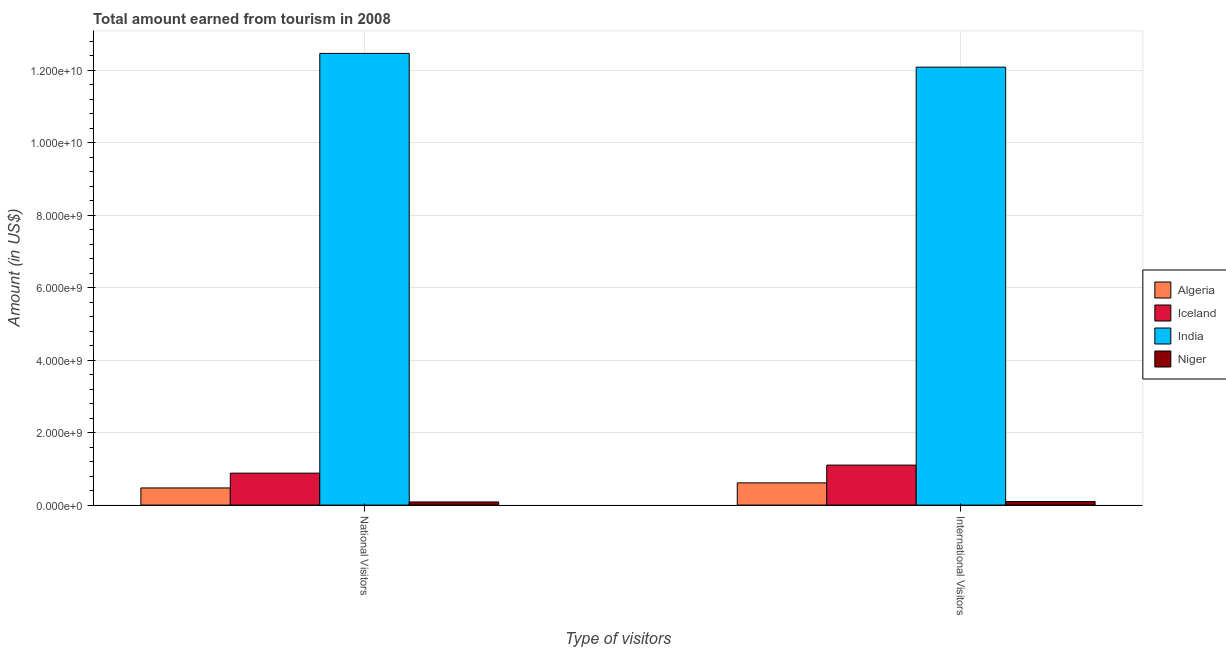How many different coloured bars are there?
Offer a terse response. 4. Are the number of bars per tick equal to the number of legend labels?
Keep it short and to the point. Yes. Are the number of bars on each tick of the X-axis equal?
Offer a very short reply. Yes. How many bars are there on the 1st tick from the left?
Your answer should be compact. 4. What is the label of the 1st group of bars from the left?
Provide a succinct answer. National Visitors. What is the amount earned from international visitors in Niger?
Your answer should be compact. 9.80e+07. Across all countries, what is the maximum amount earned from international visitors?
Your response must be concise. 1.21e+1. Across all countries, what is the minimum amount earned from international visitors?
Offer a terse response. 9.80e+07. In which country was the amount earned from international visitors minimum?
Offer a very short reply. Niger. What is the total amount earned from national visitors in the graph?
Make the answer very short. 1.39e+1. What is the difference between the amount earned from national visitors in Niger and that in Iceland?
Offer a very short reply. -7.95e+08. What is the difference between the amount earned from international visitors in Niger and the amount earned from national visitors in Iceland?
Your answer should be very brief. -7.83e+08. What is the average amount earned from international visitors per country?
Your response must be concise. 3.47e+09. What is the difference between the amount earned from international visitors and amount earned from national visitors in Iceland?
Offer a very short reply. 2.22e+08. In how many countries, is the amount earned from international visitors greater than 5600000000 US$?
Your answer should be very brief. 1. What is the ratio of the amount earned from national visitors in Niger to that in Iceland?
Offer a very short reply. 0.1. What does the 1st bar from the left in International Visitors represents?
Give a very brief answer. Algeria. What does the 1st bar from the right in National Visitors represents?
Provide a short and direct response. Niger. Are all the bars in the graph horizontal?
Offer a very short reply. No. How many countries are there in the graph?
Ensure brevity in your answer.  4. Does the graph contain any zero values?
Offer a terse response. No. Where does the legend appear in the graph?
Give a very brief answer. Center right. What is the title of the graph?
Provide a succinct answer. Total amount earned from tourism in 2008. Does "Andorra" appear as one of the legend labels in the graph?
Keep it short and to the point. No. What is the label or title of the X-axis?
Your response must be concise. Type of visitors. What is the label or title of the Y-axis?
Make the answer very short. Amount (in US$). What is the Amount (in US$) of Algeria in National Visitors?
Give a very brief answer. 4.73e+08. What is the Amount (in US$) of Iceland in National Visitors?
Your response must be concise. 8.81e+08. What is the Amount (in US$) in India in National Visitors?
Give a very brief answer. 1.25e+1. What is the Amount (in US$) in Niger in National Visitors?
Make the answer very short. 8.60e+07. What is the Amount (in US$) in Algeria in International Visitors?
Your response must be concise. 6.13e+08. What is the Amount (in US$) in Iceland in International Visitors?
Keep it short and to the point. 1.10e+09. What is the Amount (in US$) in India in International Visitors?
Offer a terse response. 1.21e+1. What is the Amount (in US$) in Niger in International Visitors?
Your answer should be compact. 9.80e+07. Across all Type of visitors, what is the maximum Amount (in US$) in Algeria?
Keep it short and to the point. 6.13e+08. Across all Type of visitors, what is the maximum Amount (in US$) in Iceland?
Ensure brevity in your answer.  1.10e+09. Across all Type of visitors, what is the maximum Amount (in US$) in India?
Make the answer very short. 1.25e+1. Across all Type of visitors, what is the maximum Amount (in US$) in Niger?
Make the answer very short. 9.80e+07. Across all Type of visitors, what is the minimum Amount (in US$) in Algeria?
Provide a short and direct response. 4.73e+08. Across all Type of visitors, what is the minimum Amount (in US$) in Iceland?
Keep it short and to the point. 8.81e+08. Across all Type of visitors, what is the minimum Amount (in US$) of India?
Make the answer very short. 1.21e+1. Across all Type of visitors, what is the minimum Amount (in US$) in Niger?
Provide a succinct answer. 8.60e+07. What is the total Amount (in US$) of Algeria in the graph?
Your answer should be compact. 1.09e+09. What is the total Amount (in US$) of Iceland in the graph?
Your answer should be compact. 1.98e+09. What is the total Amount (in US$) in India in the graph?
Provide a short and direct response. 2.45e+1. What is the total Amount (in US$) of Niger in the graph?
Your response must be concise. 1.84e+08. What is the difference between the Amount (in US$) of Algeria in National Visitors and that in International Visitors?
Your response must be concise. -1.40e+08. What is the difference between the Amount (in US$) of Iceland in National Visitors and that in International Visitors?
Keep it short and to the point. -2.22e+08. What is the difference between the Amount (in US$) of India in National Visitors and that in International Visitors?
Your answer should be very brief. 3.79e+08. What is the difference between the Amount (in US$) of Niger in National Visitors and that in International Visitors?
Your response must be concise. -1.20e+07. What is the difference between the Amount (in US$) of Algeria in National Visitors and the Amount (in US$) of Iceland in International Visitors?
Offer a very short reply. -6.30e+08. What is the difference between the Amount (in US$) in Algeria in National Visitors and the Amount (in US$) in India in International Visitors?
Provide a short and direct response. -1.16e+1. What is the difference between the Amount (in US$) in Algeria in National Visitors and the Amount (in US$) in Niger in International Visitors?
Give a very brief answer. 3.75e+08. What is the difference between the Amount (in US$) in Iceland in National Visitors and the Amount (in US$) in India in International Visitors?
Give a very brief answer. -1.12e+1. What is the difference between the Amount (in US$) of Iceland in National Visitors and the Amount (in US$) of Niger in International Visitors?
Provide a succinct answer. 7.83e+08. What is the difference between the Amount (in US$) in India in National Visitors and the Amount (in US$) in Niger in International Visitors?
Ensure brevity in your answer.  1.24e+1. What is the average Amount (in US$) of Algeria per Type of visitors?
Ensure brevity in your answer.  5.43e+08. What is the average Amount (in US$) of Iceland per Type of visitors?
Offer a terse response. 9.92e+08. What is the average Amount (in US$) of India per Type of visitors?
Offer a very short reply. 1.23e+1. What is the average Amount (in US$) of Niger per Type of visitors?
Keep it short and to the point. 9.20e+07. What is the difference between the Amount (in US$) in Algeria and Amount (in US$) in Iceland in National Visitors?
Your response must be concise. -4.08e+08. What is the difference between the Amount (in US$) in Algeria and Amount (in US$) in India in National Visitors?
Your response must be concise. -1.20e+1. What is the difference between the Amount (in US$) in Algeria and Amount (in US$) in Niger in National Visitors?
Make the answer very short. 3.87e+08. What is the difference between the Amount (in US$) in Iceland and Amount (in US$) in India in National Visitors?
Give a very brief answer. -1.16e+1. What is the difference between the Amount (in US$) in Iceland and Amount (in US$) in Niger in National Visitors?
Make the answer very short. 7.95e+08. What is the difference between the Amount (in US$) of India and Amount (in US$) of Niger in National Visitors?
Provide a succinct answer. 1.24e+1. What is the difference between the Amount (in US$) in Algeria and Amount (in US$) in Iceland in International Visitors?
Keep it short and to the point. -4.90e+08. What is the difference between the Amount (in US$) in Algeria and Amount (in US$) in India in International Visitors?
Your answer should be very brief. -1.15e+1. What is the difference between the Amount (in US$) in Algeria and Amount (in US$) in Niger in International Visitors?
Ensure brevity in your answer.  5.15e+08. What is the difference between the Amount (in US$) in Iceland and Amount (in US$) in India in International Visitors?
Make the answer very short. -1.10e+1. What is the difference between the Amount (in US$) in Iceland and Amount (in US$) in Niger in International Visitors?
Offer a terse response. 1.00e+09. What is the difference between the Amount (in US$) of India and Amount (in US$) of Niger in International Visitors?
Provide a succinct answer. 1.20e+1. What is the ratio of the Amount (in US$) of Algeria in National Visitors to that in International Visitors?
Offer a very short reply. 0.77. What is the ratio of the Amount (in US$) in Iceland in National Visitors to that in International Visitors?
Keep it short and to the point. 0.8. What is the ratio of the Amount (in US$) in India in National Visitors to that in International Visitors?
Offer a terse response. 1.03. What is the ratio of the Amount (in US$) in Niger in National Visitors to that in International Visitors?
Provide a succinct answer. 0.88. What is the difference between the highest and the second highest Amount (in US$) in Algeria?
Make the answer very short. 1.40e+08. What is the difference between the highest and the second highest Amount (in US$) in Iceland?
Provide a succinct answer. 2.22e+08. What is the difference between the highest and the second highest Amount (in US$) in India?
Provide a short and direct response. 3.79e+08. What is the difference between the highest and the lowest Amount (in US$) in Algeria?
Give a very brief answer. 1.40e+08. What is the difference between the highest and the lowest Amount (in US$) of Iceland?
Your answer should be compact. 2.22e+08. What is the difference between the highest and the lowest Amount (in US$) of India?
Ensure brevity in your answer.  3.79e+08. 